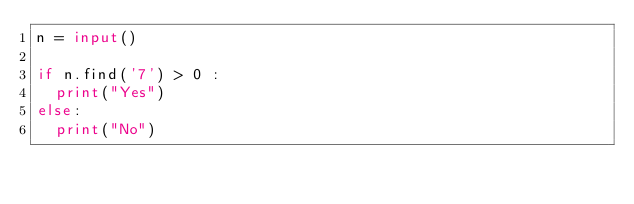<code> <loc_0><loc_0><loc_500><loc_500><_Python_>n = input()

if n.find('7') > 0 :
  print("Yes")
else:
  print("No")</code> 